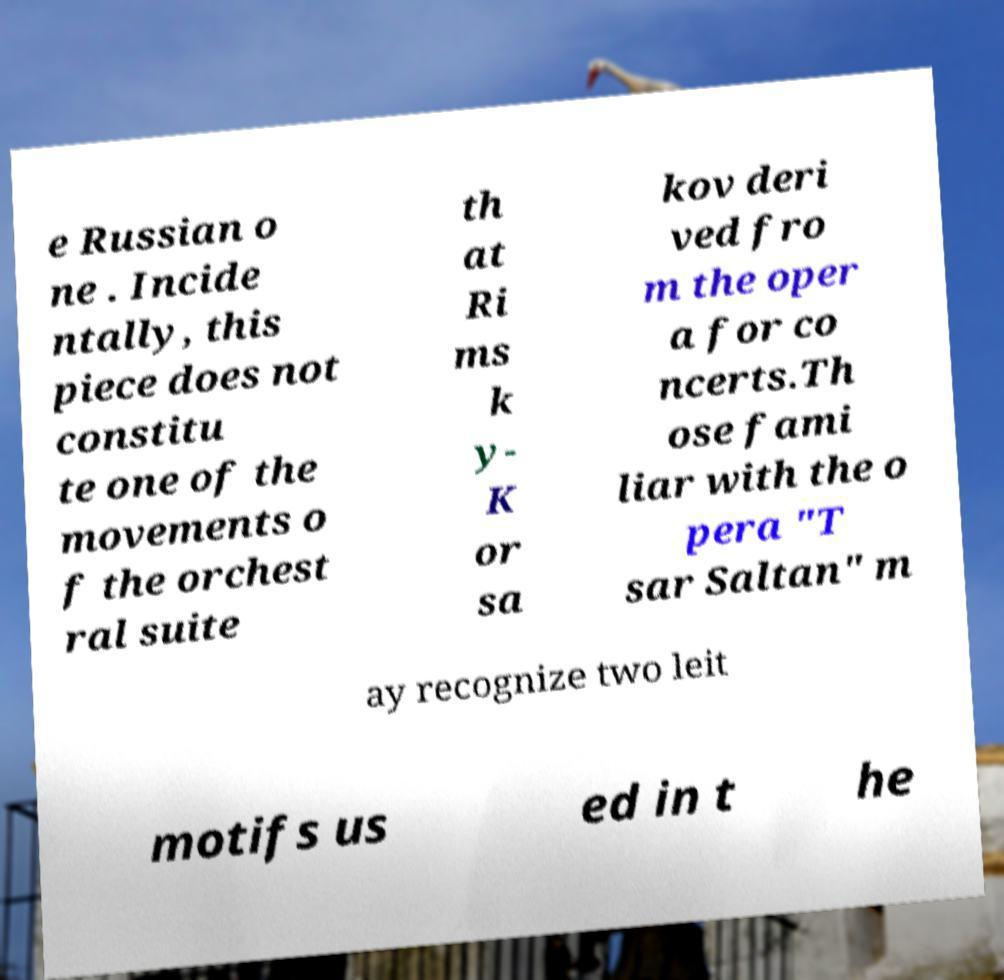Please read and relay the text visible in this image. What does it say? e Russian o ne . Incide ntally, this piece does not constitu te one of the movements o f the orchest ral suite th at Ri ms k y- K or sa kov deri ved fro m the oper a for co ncerts.Th ose fami liar with the o pera "T sar Saltan" m ay recognize two leit motifs us ed in t he 